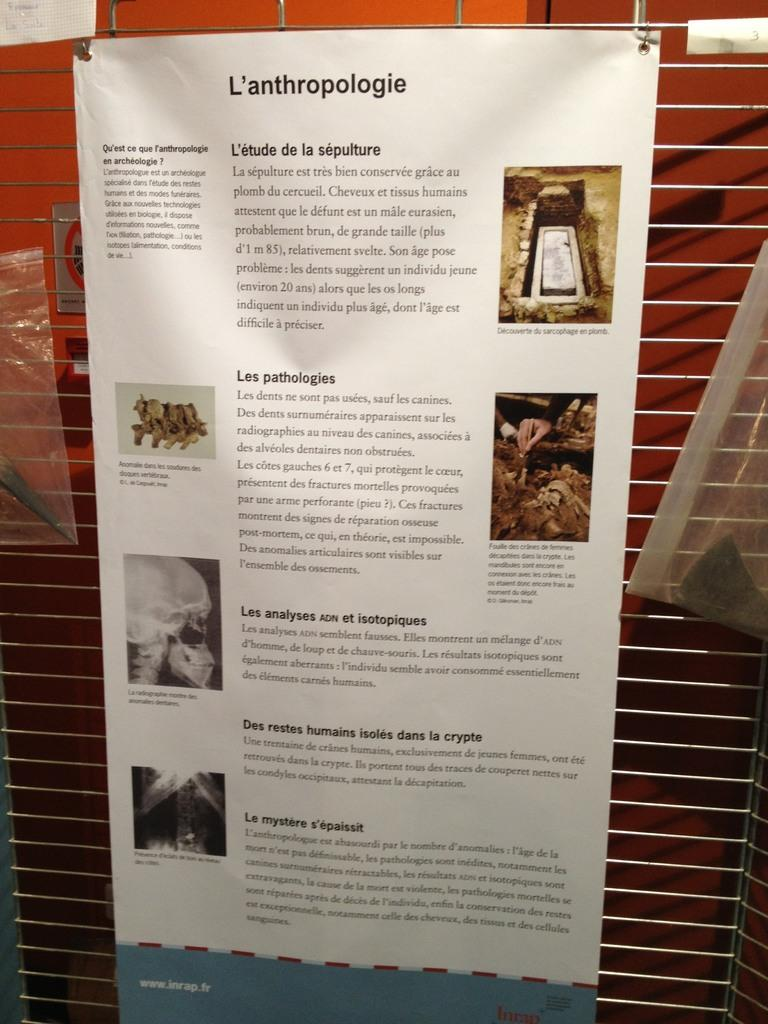<image>
Write a terse but informative summary of the picture. A paper hung on a wall that has "L'anthropologie" on the top. 